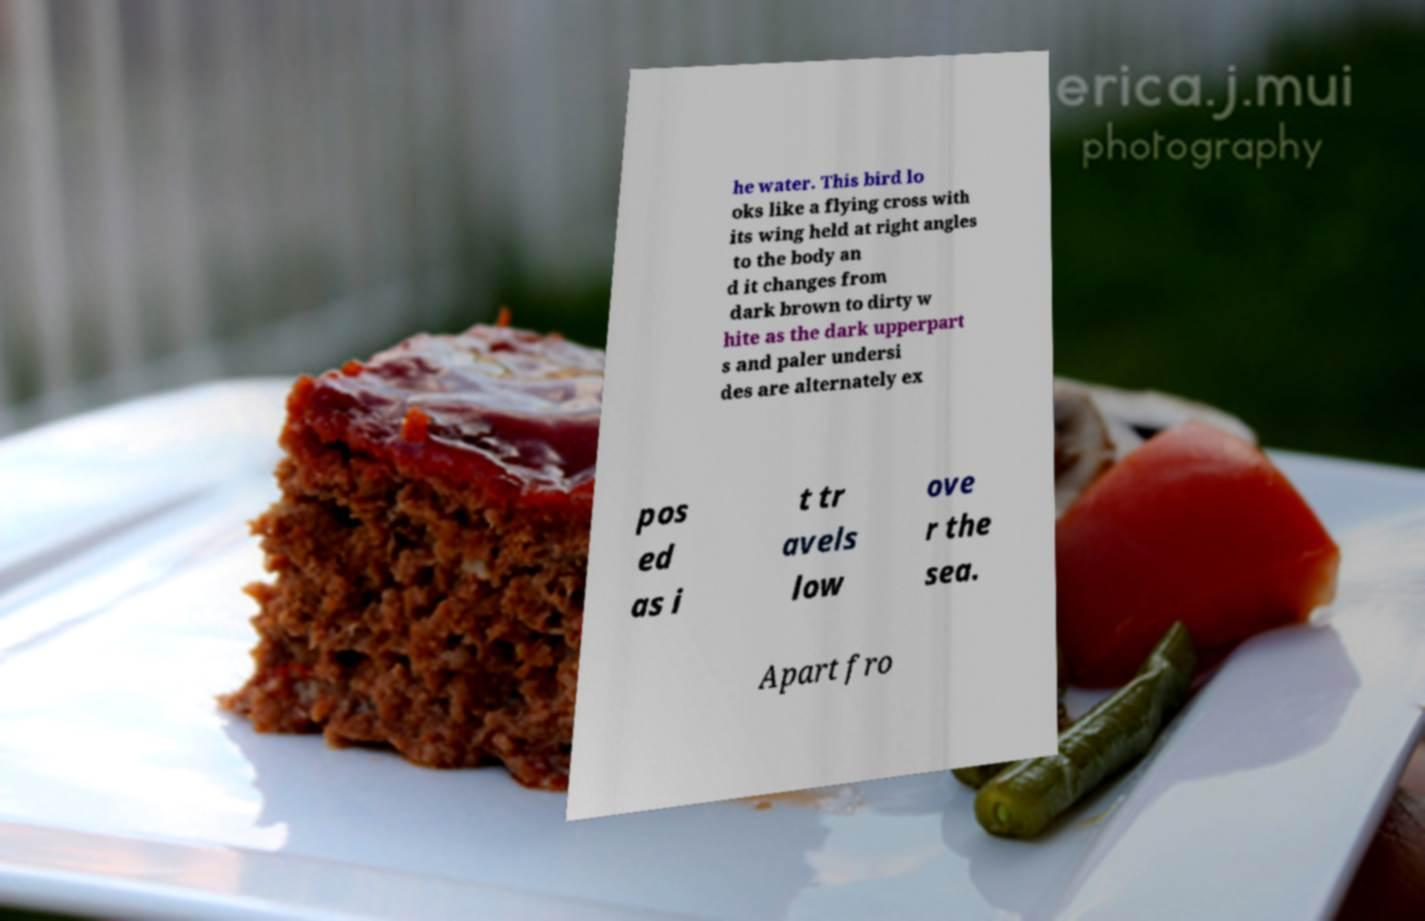Could you extract and type out the text from this image? he water. This bird lo oks like a flying cross with its wing held at right angles to the body an d it changes from dark brown to dirty w hite as the dark upperpart s and paler undersi des are alternately ex pos ed as i t tr avels low ove r the sea. Apart fro 